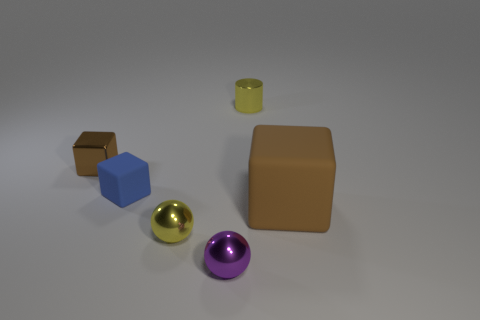Do the tiny metallic block and the big cube have the same color?
Your answer should be very brief. Yes. Is the color of the shiny thing left of the blue rubber block the same as the large rubber block?
Offer a very short reply. Yes. There is a object behind the tiny brown metal object; does it have the same color as the metallic sphere behind the purple ball?
Ensure brevity in your answer.  Yes. There is a metallic cube that is the same size as the purple sphere; what color is it?
Offer a terse response. Brown. How many tiny things are either purple balls or gray metal balls?
Keep it short and to the point. 1. There is a small object that is both behind the small matte thing and right of the small brown metallic cube; what material is it made of?
Make the answer very short. Metal. Do the object that is to the right of the tiny yellow cylinder and the rubber thing that is behind the big matte block have the same shape?
Keep it short and to the point. Yes. There is a thing that is the same color as the metallic cube; what shape is it?
Your answer should be compact. Cube. How many objects are tiny yellow metal things behind the brown rubber block or cyan metal cubes?
Provide a short and direct response. 1. Is the size of the purple metal ball the same as the brown rubber block?
Offer a terse response. No. 